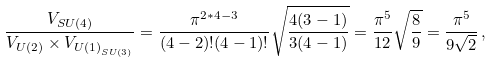<formula> <loc_0><loc_0><loc_500><loc_500>\frac { V _ { S U ( 4 ) } } { V _ { U ( 2 ) } \times V _ { { U ( 1 ) } _ { S U ( 3 ) } } } = \frac { \pi ^ { 2 * 4 - 3 } } { ( 4 - 2 ) ! ( 4 - 1 ) ! } \sqrt { \frac { 4 ( 3 - 1 ) } { 3 ( 4 - 1 ) } } = \frac { \pi ^ { 5 } } { 1 2 } \sqrt { \frac { 8 } { 9 } } = \frac { \pi ^ { 5 } } { 9 \sqrt { 2 } } \, ,</formula> 